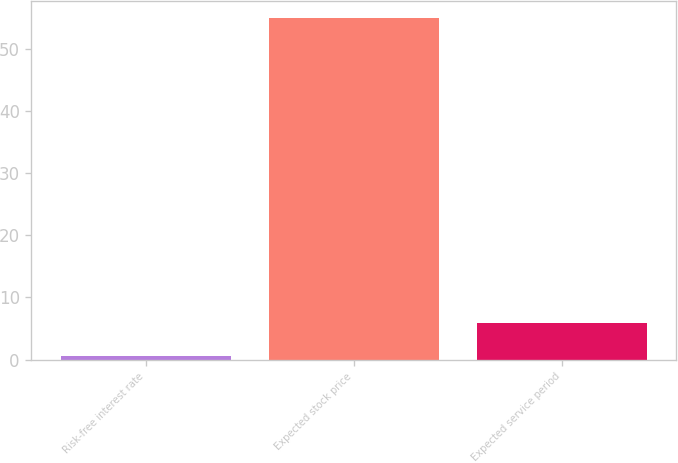Convert chart to OTSL. <chart><loc_0><loc_0><loc_500><loc_500><bar_chart><fcel>Risk-free interest rate<fcel>Expected stock price<fcel>Expected service period<nl><fcel>0.5<fcel>55<fcel>5.95<nl></chart> 